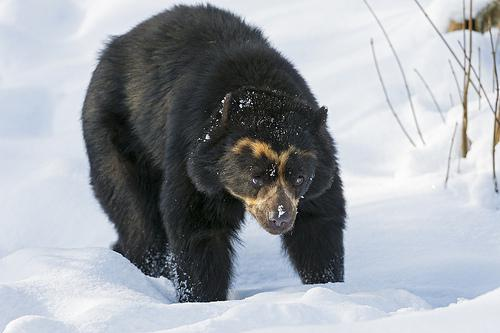Question: what animal is this?
Choices:
A. Dog.
B. Lion.
C. Bear.
D. Tiger.
Answer with the letter. Answer: C Question: what is on the ground?
Choices:
A. Grass.
B. Mud.
C. Rocks.
D. Snow.
Answer with the letter. Answer: D Question: where was this photo taken?
Choices:
A. On the beach.
B. Outside in the snow.
C. In the mountains.
D. In a forest.
Answer with the letter. Answer: B Question: how many of the bear's eyes are open?
Choices:
A. 5.
B. 6.
C. 2.
D. 3.
Answer with the letter. Answer: C 